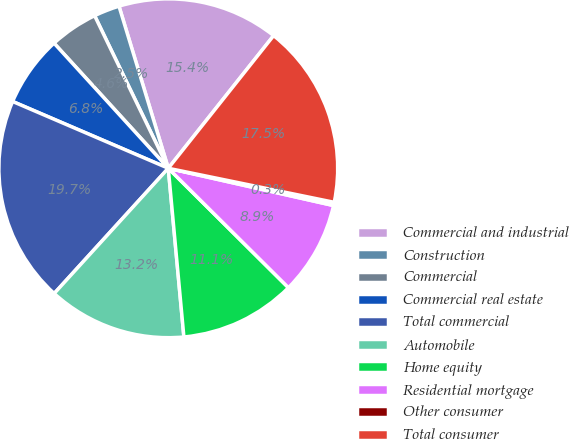<chart> <loc_0><loc_0><loc_500><loc_500><pie_chart><fcel>Commercial and industrial<fcel>Construction<fcel>Commercial<fcel>Commercial real estate<fcel>Total commercial<fcel>Automobile<fcel>Home equity<fcel>Residential mortgage<fcel>Other consumer<fcel>Total consumer<nl><fcel>15.38%<fcel>2.46%<fcel>4.62%<fcel>6.77%<fcel>19.69%<fcel>13.23%<fcel>11.08%<fcel>8.92%<fcel>0.31%<fcel>17.54%<nl></chart> 